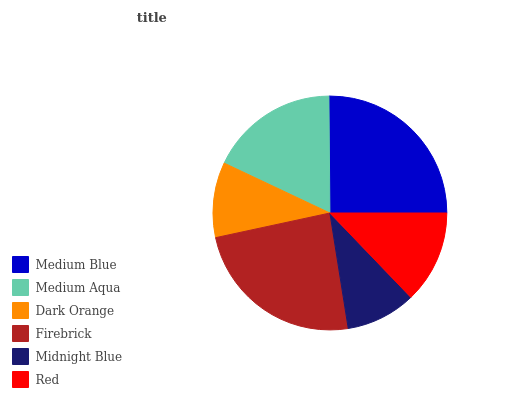Is Midnight Blue the minimum?
Answer yes or no. Yes. Is Medium Blue the maximum?
Answer yes or no. Yes. Is Medium Aqua the minimum?
Answer yes or no. No. Is Medium Aqua the maximum?
Answer yes or no. No. Is Medium Blue greater than Medium Aqua?
Answer yes or no. Yes. Is Medium Aqua less than Medium Blue?
Answer yes or no. Yes. Is Medium Aqua greater than Medium Blue?
Answer yes or no. No. Is Medium Blue less than Medium Aqua?
Answer yes or no. No. Is Medium Aqua the high median?
Answer yes or no. Yes. Is Red the low median?
Answer yes or no. Yes. Is Red the high median?
Answer yes or no. No. Is Midnight Blue the low median?
Answer yes or no. No. 